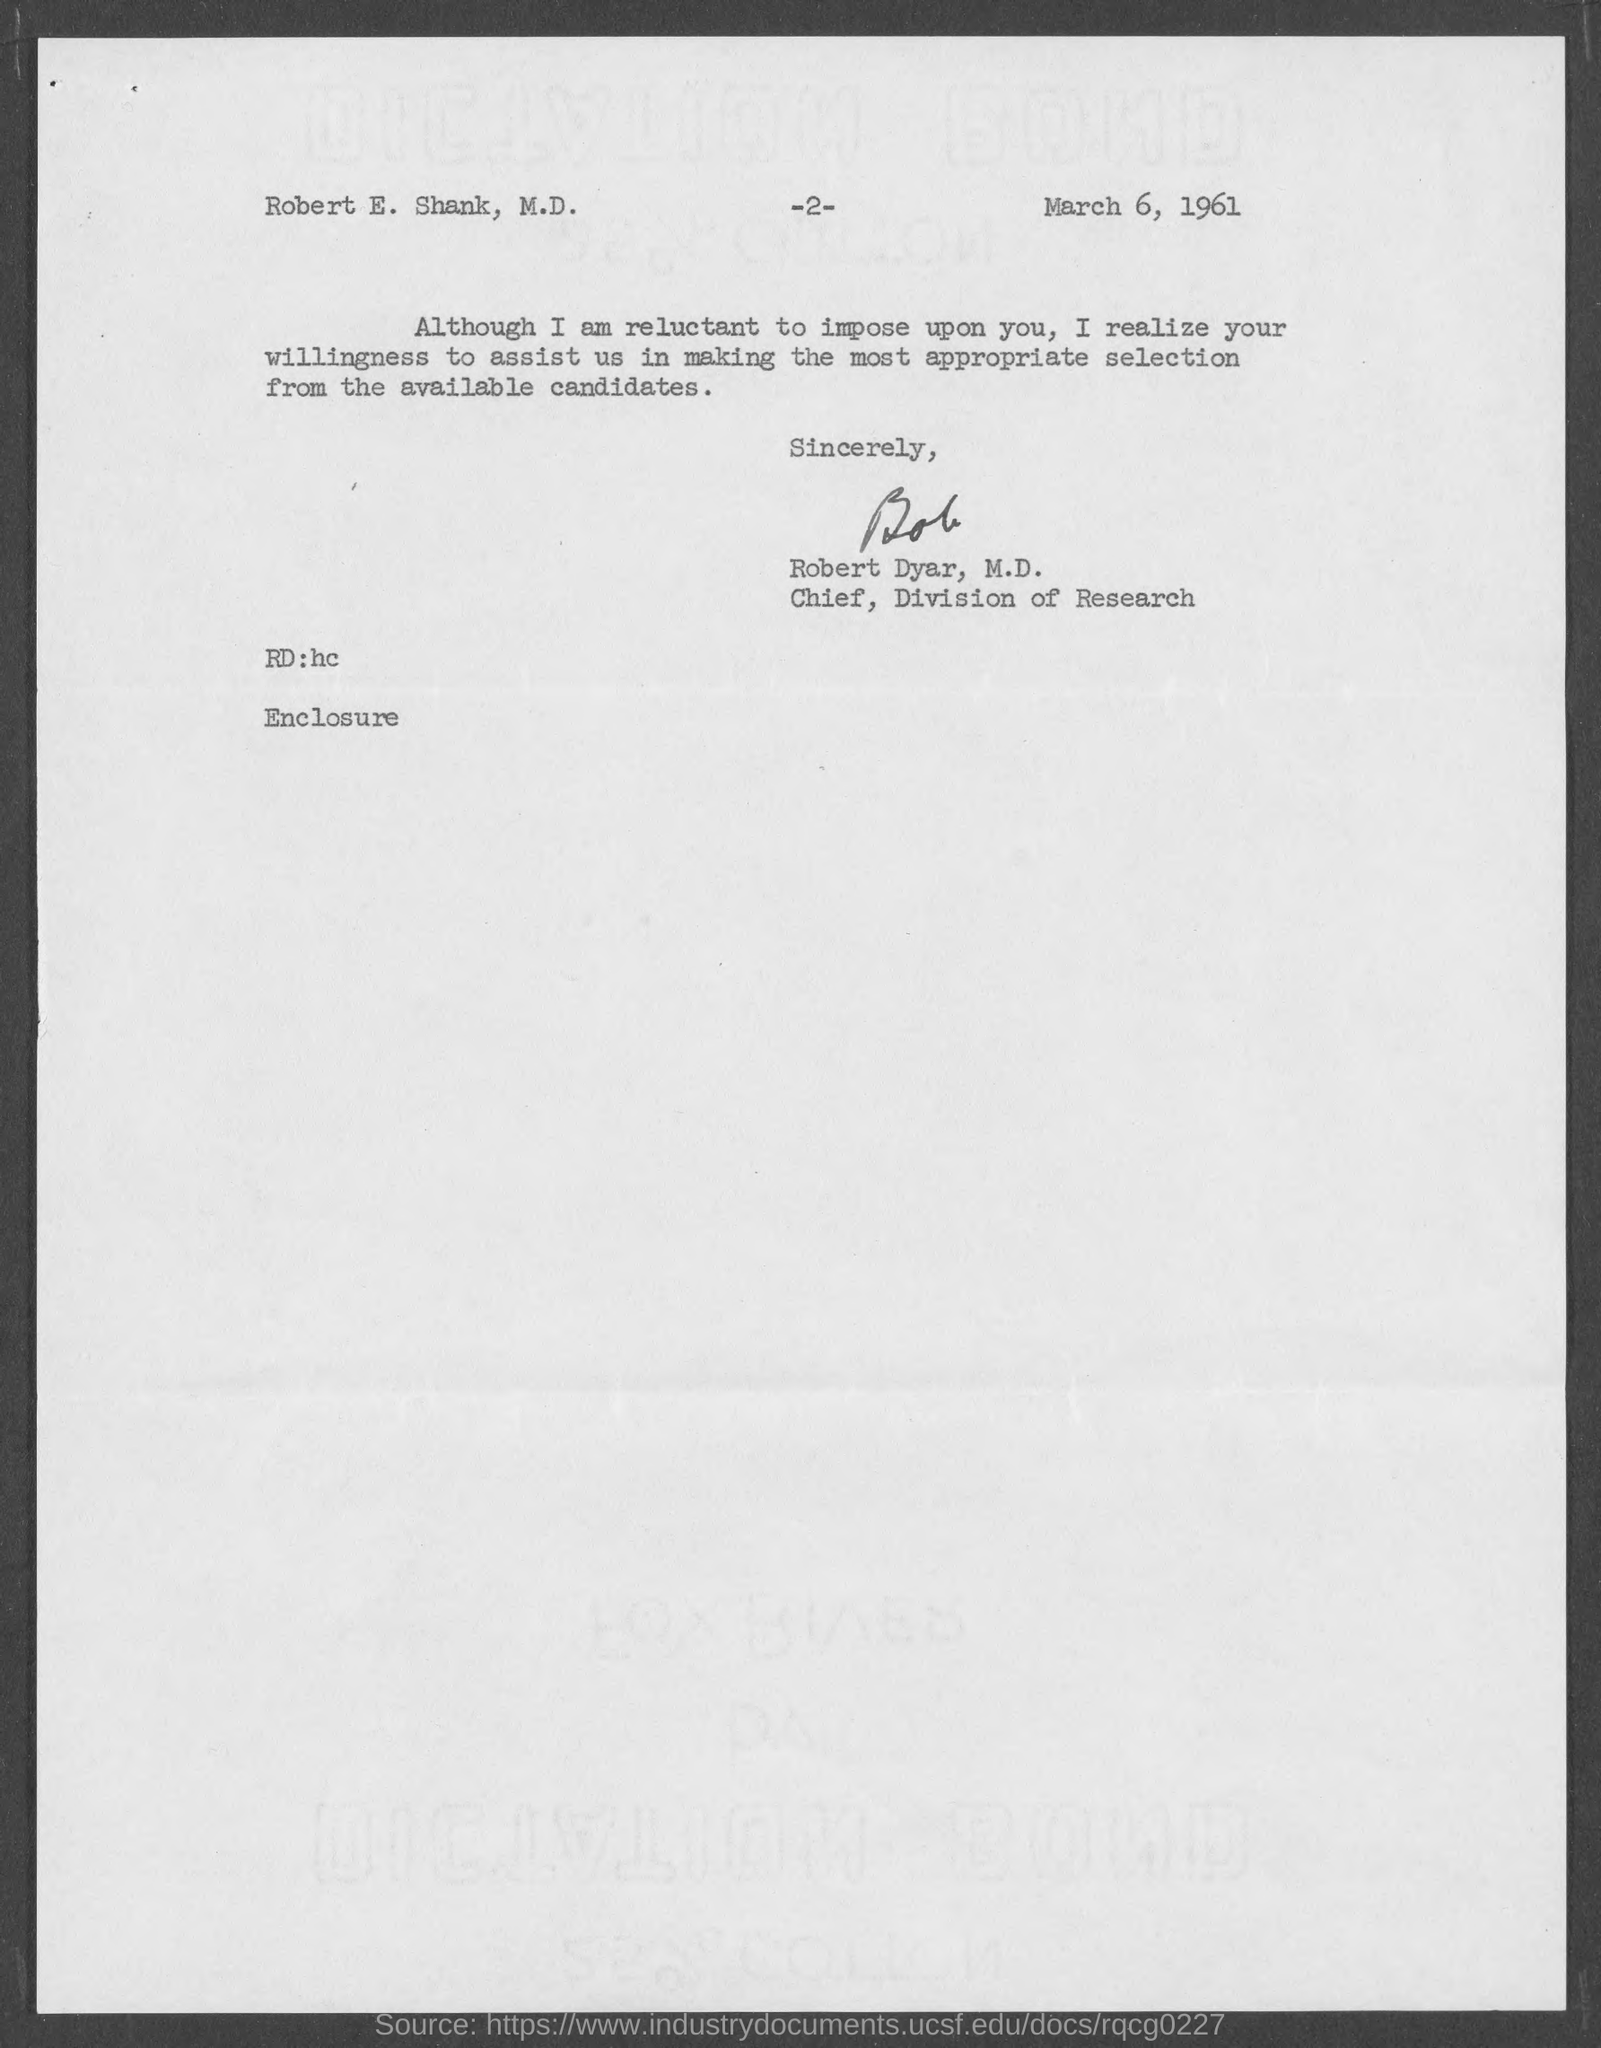What is the date mentioned in the document ?
Your response must be concise. March 6, 1961. Who is the Chief, Division of Research ?
Your response must be concise. Robert Dyar. What is the page number ?
Give a very brief answer. 2. 